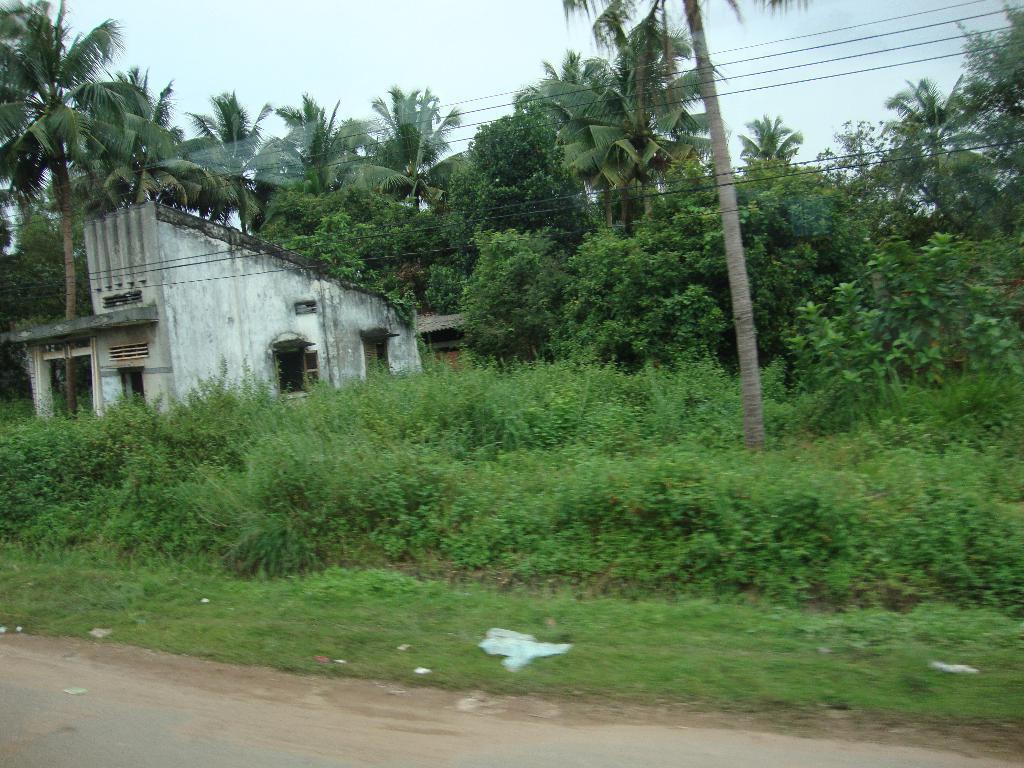Please provide a concise description of this image. In this picture we can see grass, plants, few trees, cables and houses. 